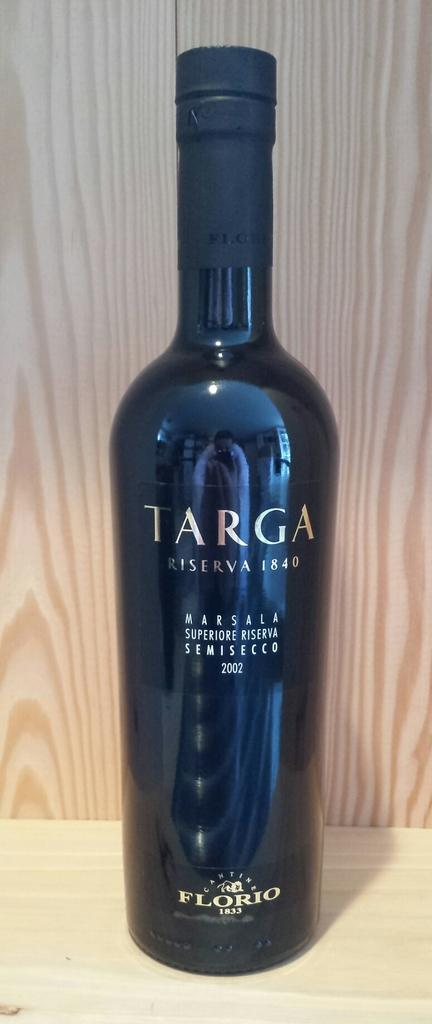<image>
Create a compact narrative representing the image presented. the word targa that is on a wine bottle 